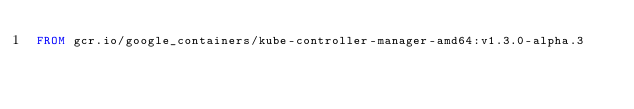<code> <loc_0><loc_0><loc_500><loc_500><_Dockerfile_>FROM gcr.io/google_containers/kube-controller-manager-amd64:v1.3.0-alpha.3
</code> 